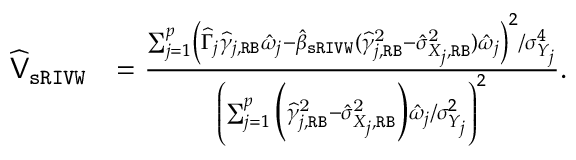<formula> <loc_0><loc_0><loc_500><loc_500>\begin{array} { r l } { \widehat { V } _ { s R I V W } } & { = \frac { \sum _ { j = 1 } ^ { p } \left ( \widehat { \Gamma } _ { j } \widehat { \gamma } _ { j , R B } \hat { \omega } _ { j } - \hat { \beta } _ { s R I V W } ( \widehat { \gamma } _ { j , R B } ^ { 2 } - \hat { \sigma } _ { X _ { j } , R B } ^ { 2 } ) \hat { \omega } _ { j } \right ) ^ { 2 } / \sigma _ { Y _ { j } } ^ { 4 } } { \left ( \sum _ { j = 1 } ^ { p } \left ( \widehat { \gamma } _ { j , R B } ^ { 2 } - \hat { \sigma } _ { X _ { j } , R B } ^ { 2 } \right ) \hat { \omega } _ { j } / \sigma _ { Y _ { j } } ^ { 2 } \right ) ^ { 2 } } . } \end{array}</formula> 